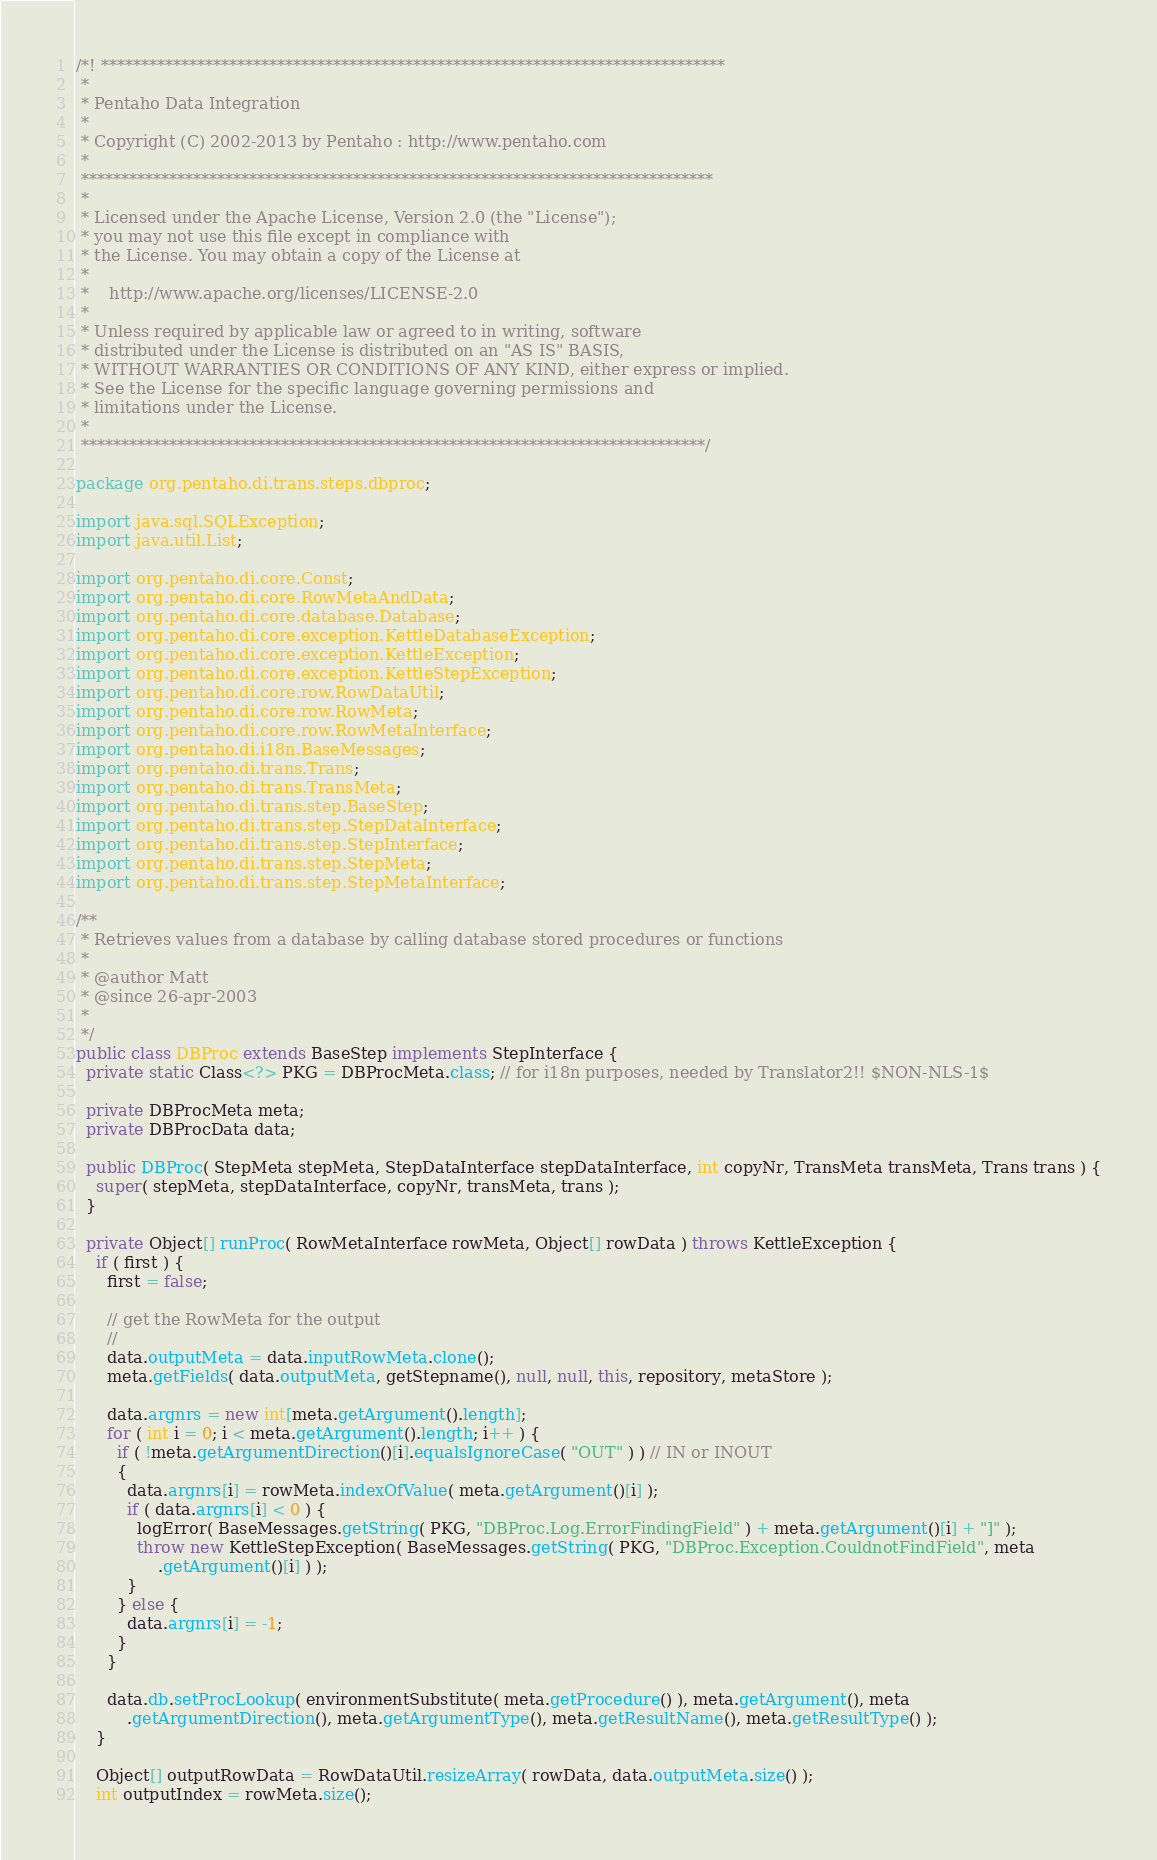<code> <loc_0><loc_0><loc_500><loc_500><_Java_>/*! ******************************************************************************
 *
 * Pentaho Data Integration
 *
 * Copyright (C) 2002-2013 by Pentaho : http://www.pentaho.com
 *
 *******************************************************************************
 *
 * Licensed under the Apache License, Version 2.0 (the "License");
 * you may not use this file except in compliance with
 * the License. You may obtain a copy of the License at
 *
 *    http://www.apache.org/licenses/LICENSE-2.0
 *
 * Unless required by applicable law or agreed to in writing, software
 * distributed under the License is distributed on an "AS IS" BASIS,
 * WITHOUT WARRANTIES OR CONDITIONS OF ANY KIND, either express or implied.
 * See the License for the specific language governing permissions and
 * limitations under the License.
 *
 ******************************************************************************/

package org.pentaho.di.trans.steps.dbproc;

import java.sql.SQLException;
import java.util.List;

import org.pentaho.di.core.Const;
import org.pentaho.di.core.RowMetaAndData;
import org.pentaho.di.core.database.Database;
import org.pentaho.di.core.exception.KettleDatabaseException;
import org.pentaho.di.core.exception.KettleException;
import org.pentaho.di.core.exception.KettleStepException;
import org.pentaho.di.core.row.RowDataUtil;
import org.pentaho.di.core.row.RowMeta;
import org.pentaho.di.core.row.RowMetaInterface;
import org.pentaho.di.i18n.BaseMessages;
import org.pentaho.di.trans.Trans;
import org.pentaho.di.trans.TransMeta;
import org.pentaho.di.trans.step.BaseStep;
import org.pentaho.di.trans.step.StepDataInterface;
import org.pentaho.di.trans.step.StepInterface;
import org.pentaho.di.trans.step.StepMeta;
import org.pentaho.di.trans.step.StepMetaInterface;

/**
 * Retrieves values from a database by calling database stored procedures or functions
 * 
 * @author Matt
 * @since 26-apr-2003
 * 
 */
public class DBProc extends BaseStep implements StepInterface {
  private static Class<?> PKG = DBProcMeta.class; // for i18n purposes, needed by Translator2!! $NON-NLS-1$

  private DBProcMeta meta;
  private DBProcData data;

  public DBProc( StepMeta stepMeta, StepDataInterface stepDataInterface, int copyNr, TransMeta transMeta, Trans trans ) {
    super( stepMeta, stepDataInterface, copyNr, transMeta, trans );
  }

  private Object[] runProc( RowMetaInterface rowMeta, Object[] rowData ) throws KettleException {
    if ( first ) {
      first = false;

      // get the RowMeta for the output
      //
      data.outputMeta = data.inputRowMeta.clone();
      meta.getFields( data.outputMeta, getStepname(), null, null, this, repository, metaStore );

      data.argnrs = new int[meta.getArgument().length];
      for ( int i = 0; i < meta.getArgument().length; i++ ) {
        if ( !meta.getArgumentDirection()[i].equalsIgnoreCase( "OUT" ) ) // IN or INOUT
        {
          data.argnrs[i] = rowMeta.indexOfValue( meta.getArgument()[i] );
          if ( data.argnrs[i] < 0 ) {
            logError( BaseMessages.getString( PKG, "DBProc.Log.ErrorFindingField" ) + meta.getArgument()[i] + "]" );
            throw new KettleStepException( BaseMessages.getString( PKG, "DBProc.Exception.CouldnotFindField", meta
                .getArgument()[i] ) );
          }
        } else {
          data.argnrs[i] = -1;
        }
      }

      data.db.setProcLookup( environmentSubstitute( meta.getProcedure() ), meta.getArgument(), meta
          .getArgumentDirection(), meta.getArgumentType(), meta.getResultName(), meta.getResultType() );
    }

    Object[] outputRowData = RowDataUtil.resizeArray( rowData, data.outputMeta.size() );
    int outputIndex = rowMeta.size();
</code> 